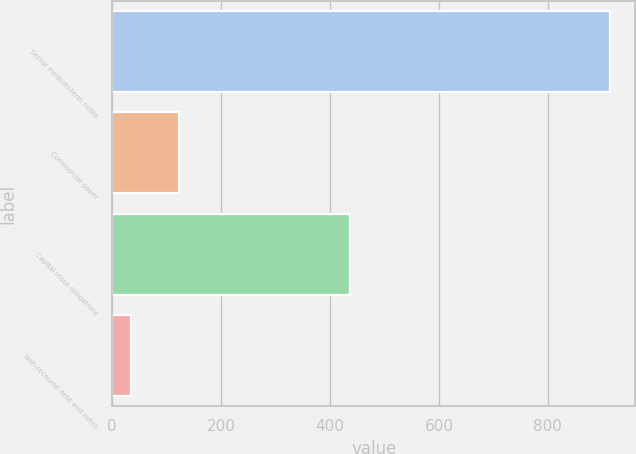Convert chart. <chart><loc_0><loc_0><loc_500><loc_500><bar_chart><fcel>Senior medium-term notes<fcel>Commercial paper<fcel>Capital lease obligations<fcel>Non-recourse debt and notes<nl><fcel>915<fcel>123<fcel>437<fcel>35<nl></chart> 